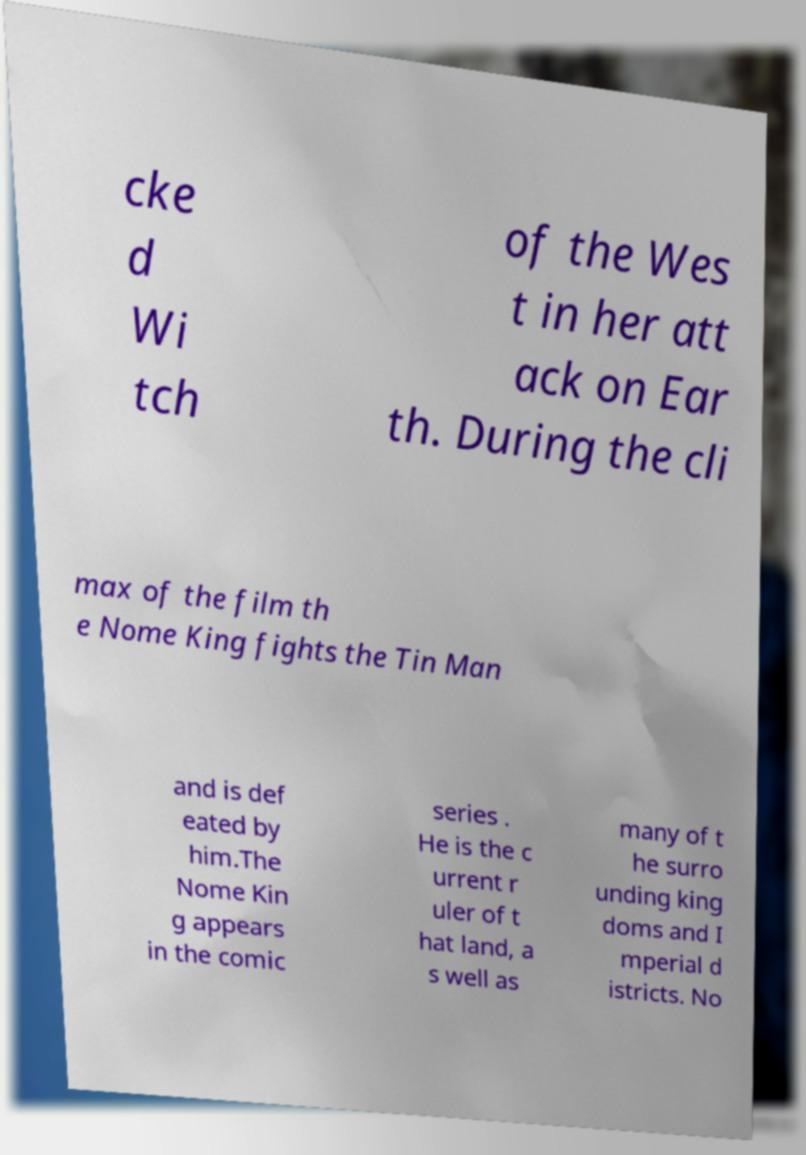Can you read and provide the text displayed in the image?This photo seems to have some interesting text. Can you extract and type it out for me? cke d Wi tch of the Wes t in her att ack on Ear th. During the cli max of the film th e Nome King fights the Tin Man and is def eated by him.The Nome Kin g appears in the comic series . He is the c urrent r uler of t hat land, a s well as many of t he surro unding king doms and I mperial d istricts. No 